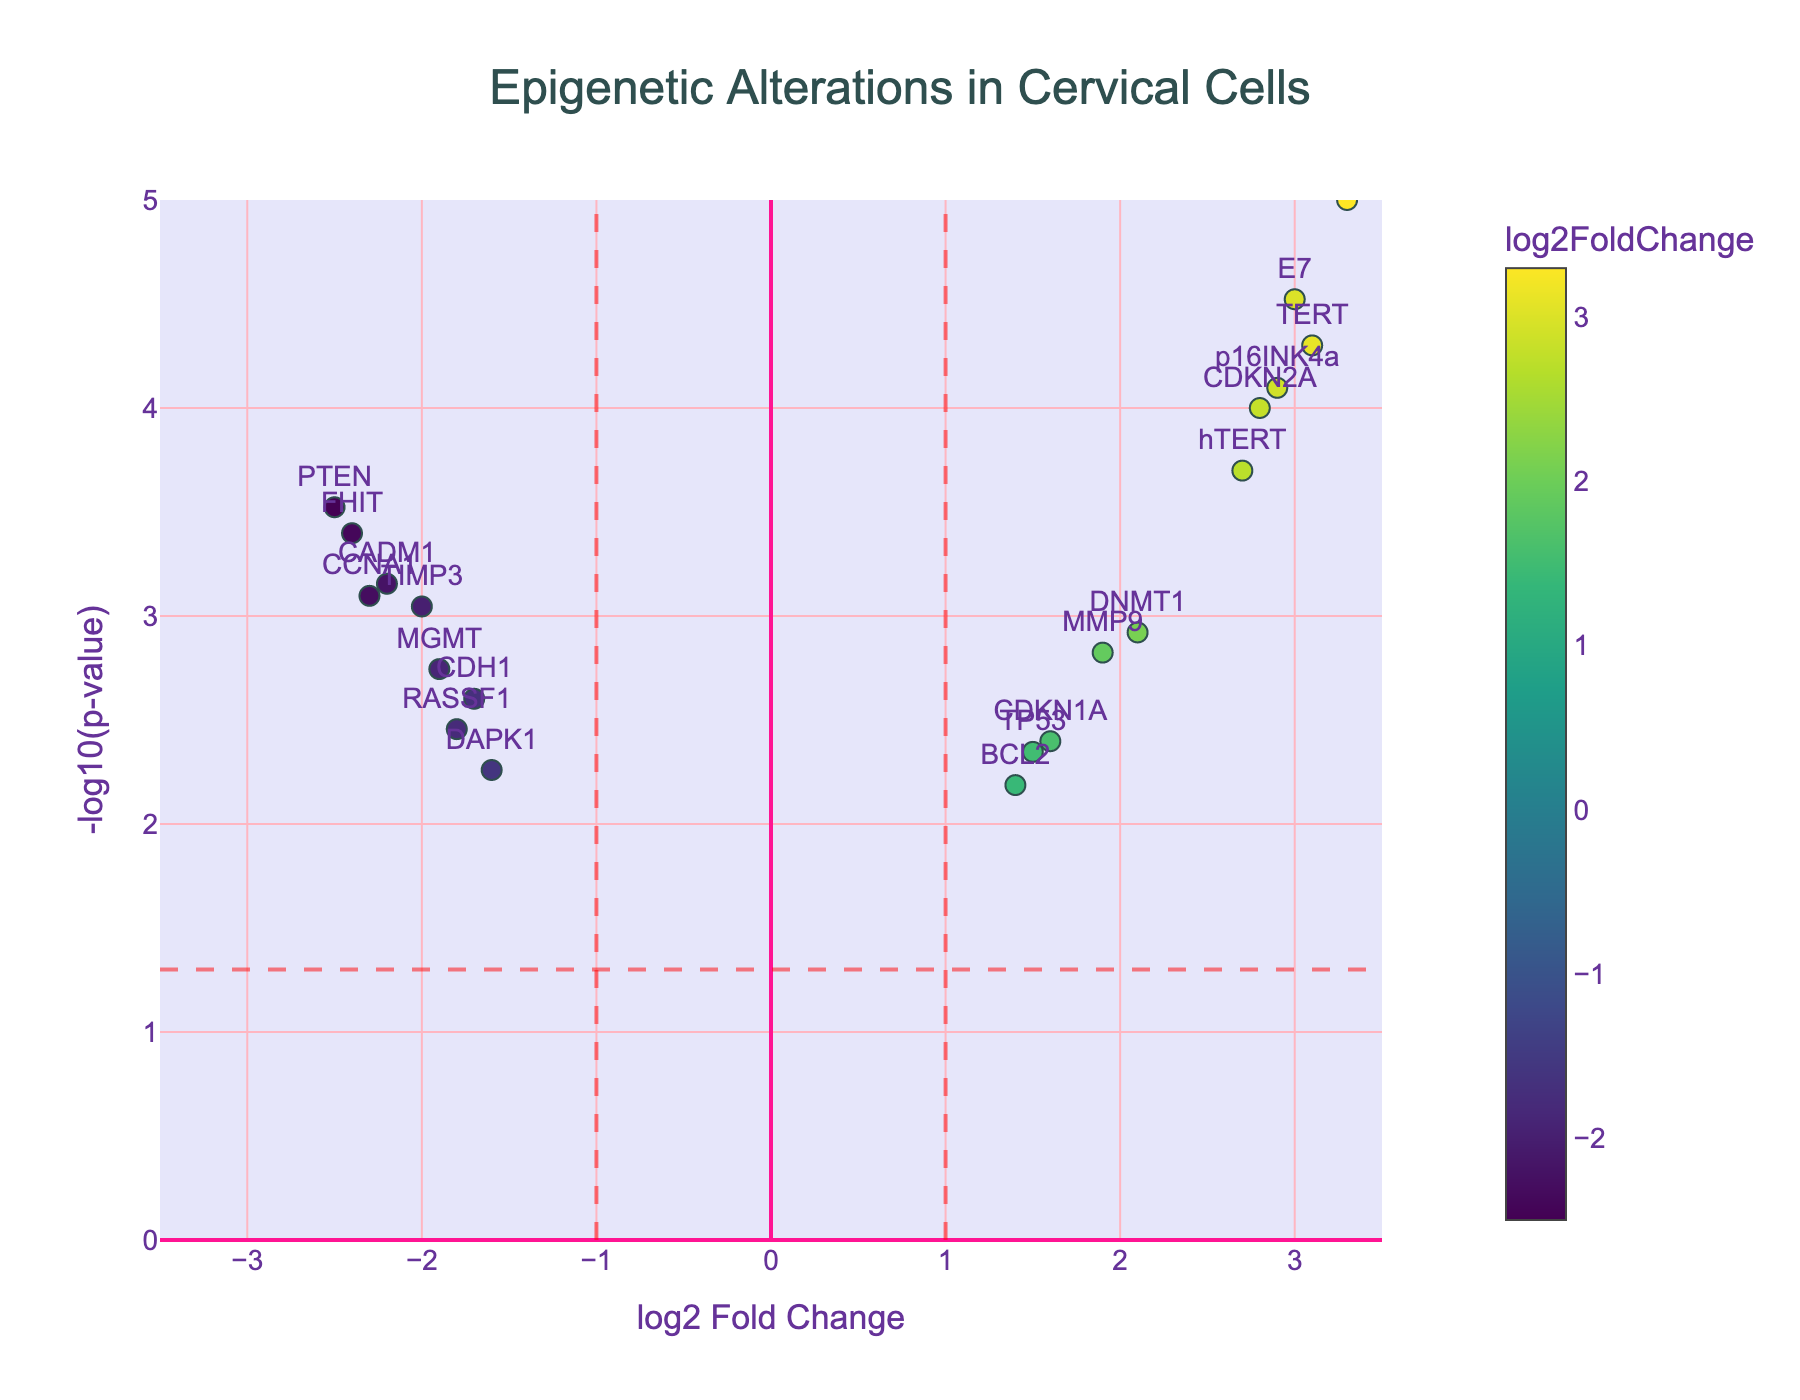What is the title of the figure? Look at the text at the top center of the figure. The text says "Epigenetic Alterations in Cervical Cells".
Answer: Epigenetic Alterations in Cervical Cells What log2 fold change value represents the vertical red dashed lines in the plot? The red dashed lines mark the threshold for significant log2 fold change values. These lines are placed at log2 fold change values of 1 and -1.
Answer: 1 and -1 Which gene has the highest log2 fold change? Locate the point farthest to the right on the x-axis. The corresponding text, "E6", identifies the gene with the highest log2 fold change.
Answer: E6 How many genes have a p-value less than 0.0001? Check the points above the red dashed horizontal line at -log10(p-value) of 4 (equivalent to p-value of 0.0001). There are three points (E6, TERT, and E7).
Answer: 3 What is the log2 fold change and p-value of the CDKN2A gene? Find the point labeled "CDKN2A". The hover text or marker placement indicates it has a log2 fold change of 2.8 and a p-value of 0.0001.
Answer: 2.8, 0.0001 Which genes have a negative log2 fold change and a p-value less than 0.001? Cross-reference the points to the left of the red line at log2 fold change -1 and above the horizontal line at -log10(p-value) of 3 (p-value = 0.001). The genes are CCNA1, CADM1, and FHIT.
Answer: CCNA1, CADM1, FHIT Compare the log2 fold change values for the genes CDH1 and BCL2. Which one is higher? Locate both points on the x-axis and compare their positions. BCL2 has a log2 fold change of 1.4, whereas CDH1 has -1.7. BCL2’s value is higher.
Answer: BCL2 Which genes are labeled at the top center of their corresponding points? Examine the labeling text positions on the scatter plot. The genes CDKN2A, MMP9, TERT, CCNA1, DNMT1, hTERT, BCL2, TP53, CDKN1A, E6, E7, and p16INK4a are labeled at the top center.
Answer: CDKN2A, MMP9, TERT, CCNA1, DNMT1, hTERT, BCL2, TP53, CDKN1A, E6, E7, p16INK4a What is the approximate -log10(p-value) for the gene TP53? Find TP53 on the y-axis. Its approximate -log10(p-value) is around 2.4 based on its vertical position.
Answer: 2.4 